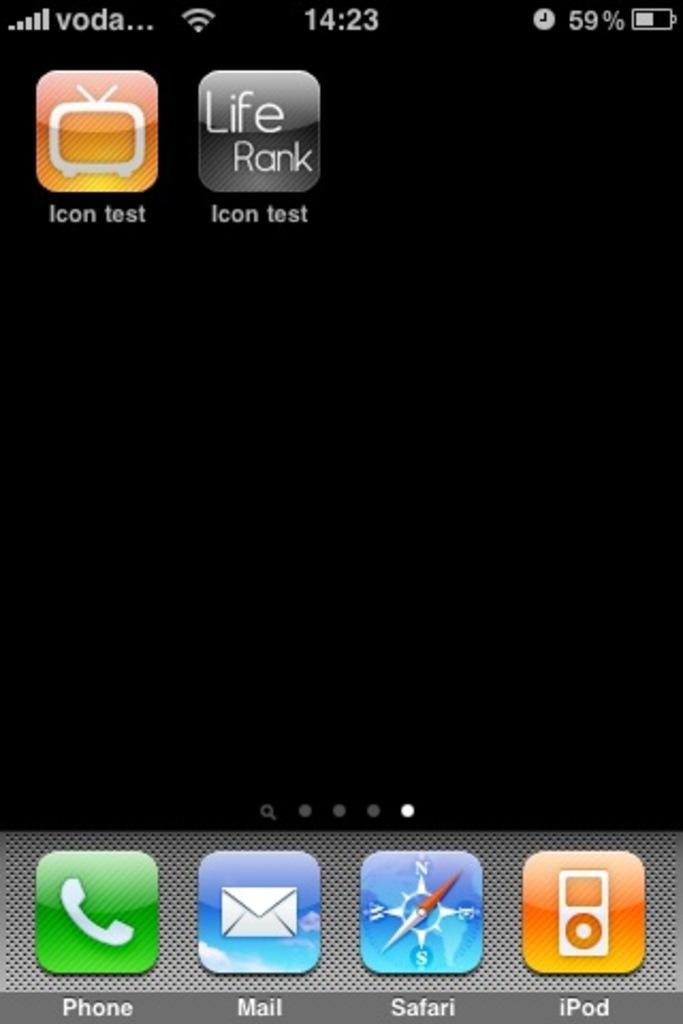<image>
Summarize the visual content of the image. The screen of a cell phone has Icon test and Life Rank as the shown apps. 